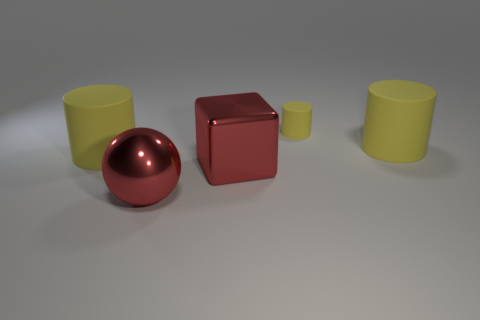Subtract all yellow cylinders. How many were subtracted if there are2yellow cylinders left? 1 Add 5 brown blocks. How many objects exist? 10 Subtract all cubes. How many objects are left? 4 Add 4 blue things. How many blue things exist? 4 Subtract 2 yellow cylinders. How many objects are left? 3 Subtract all yellow things. Subtract all big metallic cubes. How many objects are left? 1 Add 1 large cylinders. How many large cylinders are left? 3 